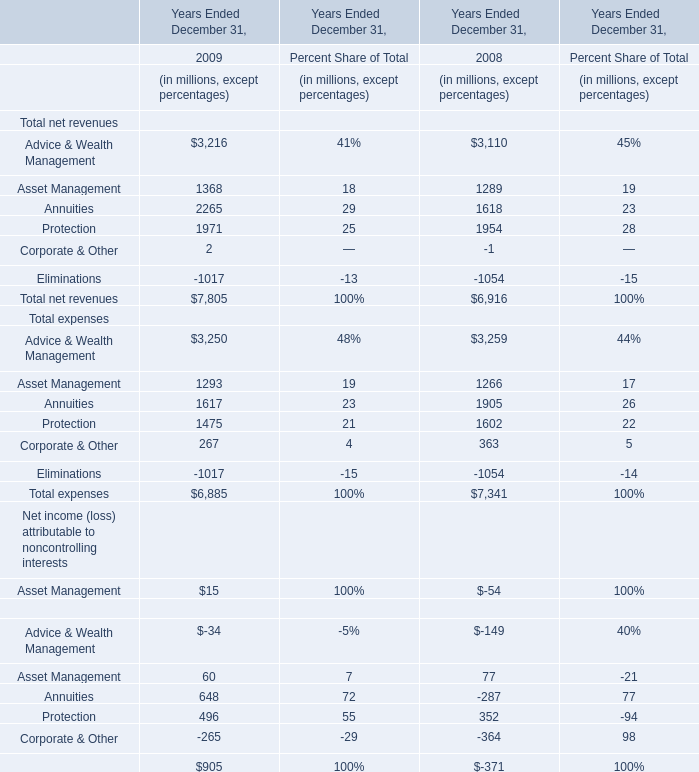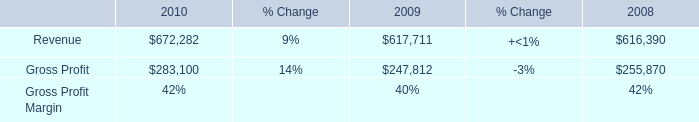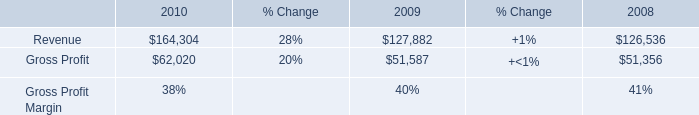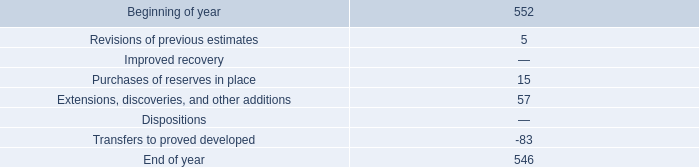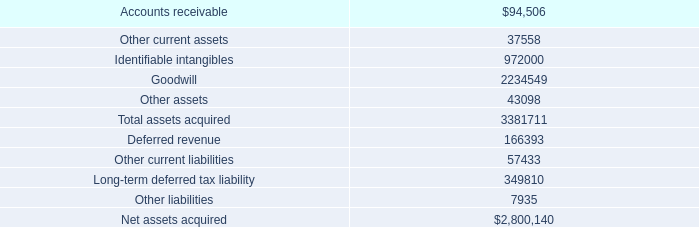What is the growing rate of Revenue in Table 1 in the year with the most Annuities in Table 0? 
Computations: ((617711 - 616390) / 616390)
Answer: 0.00214. 